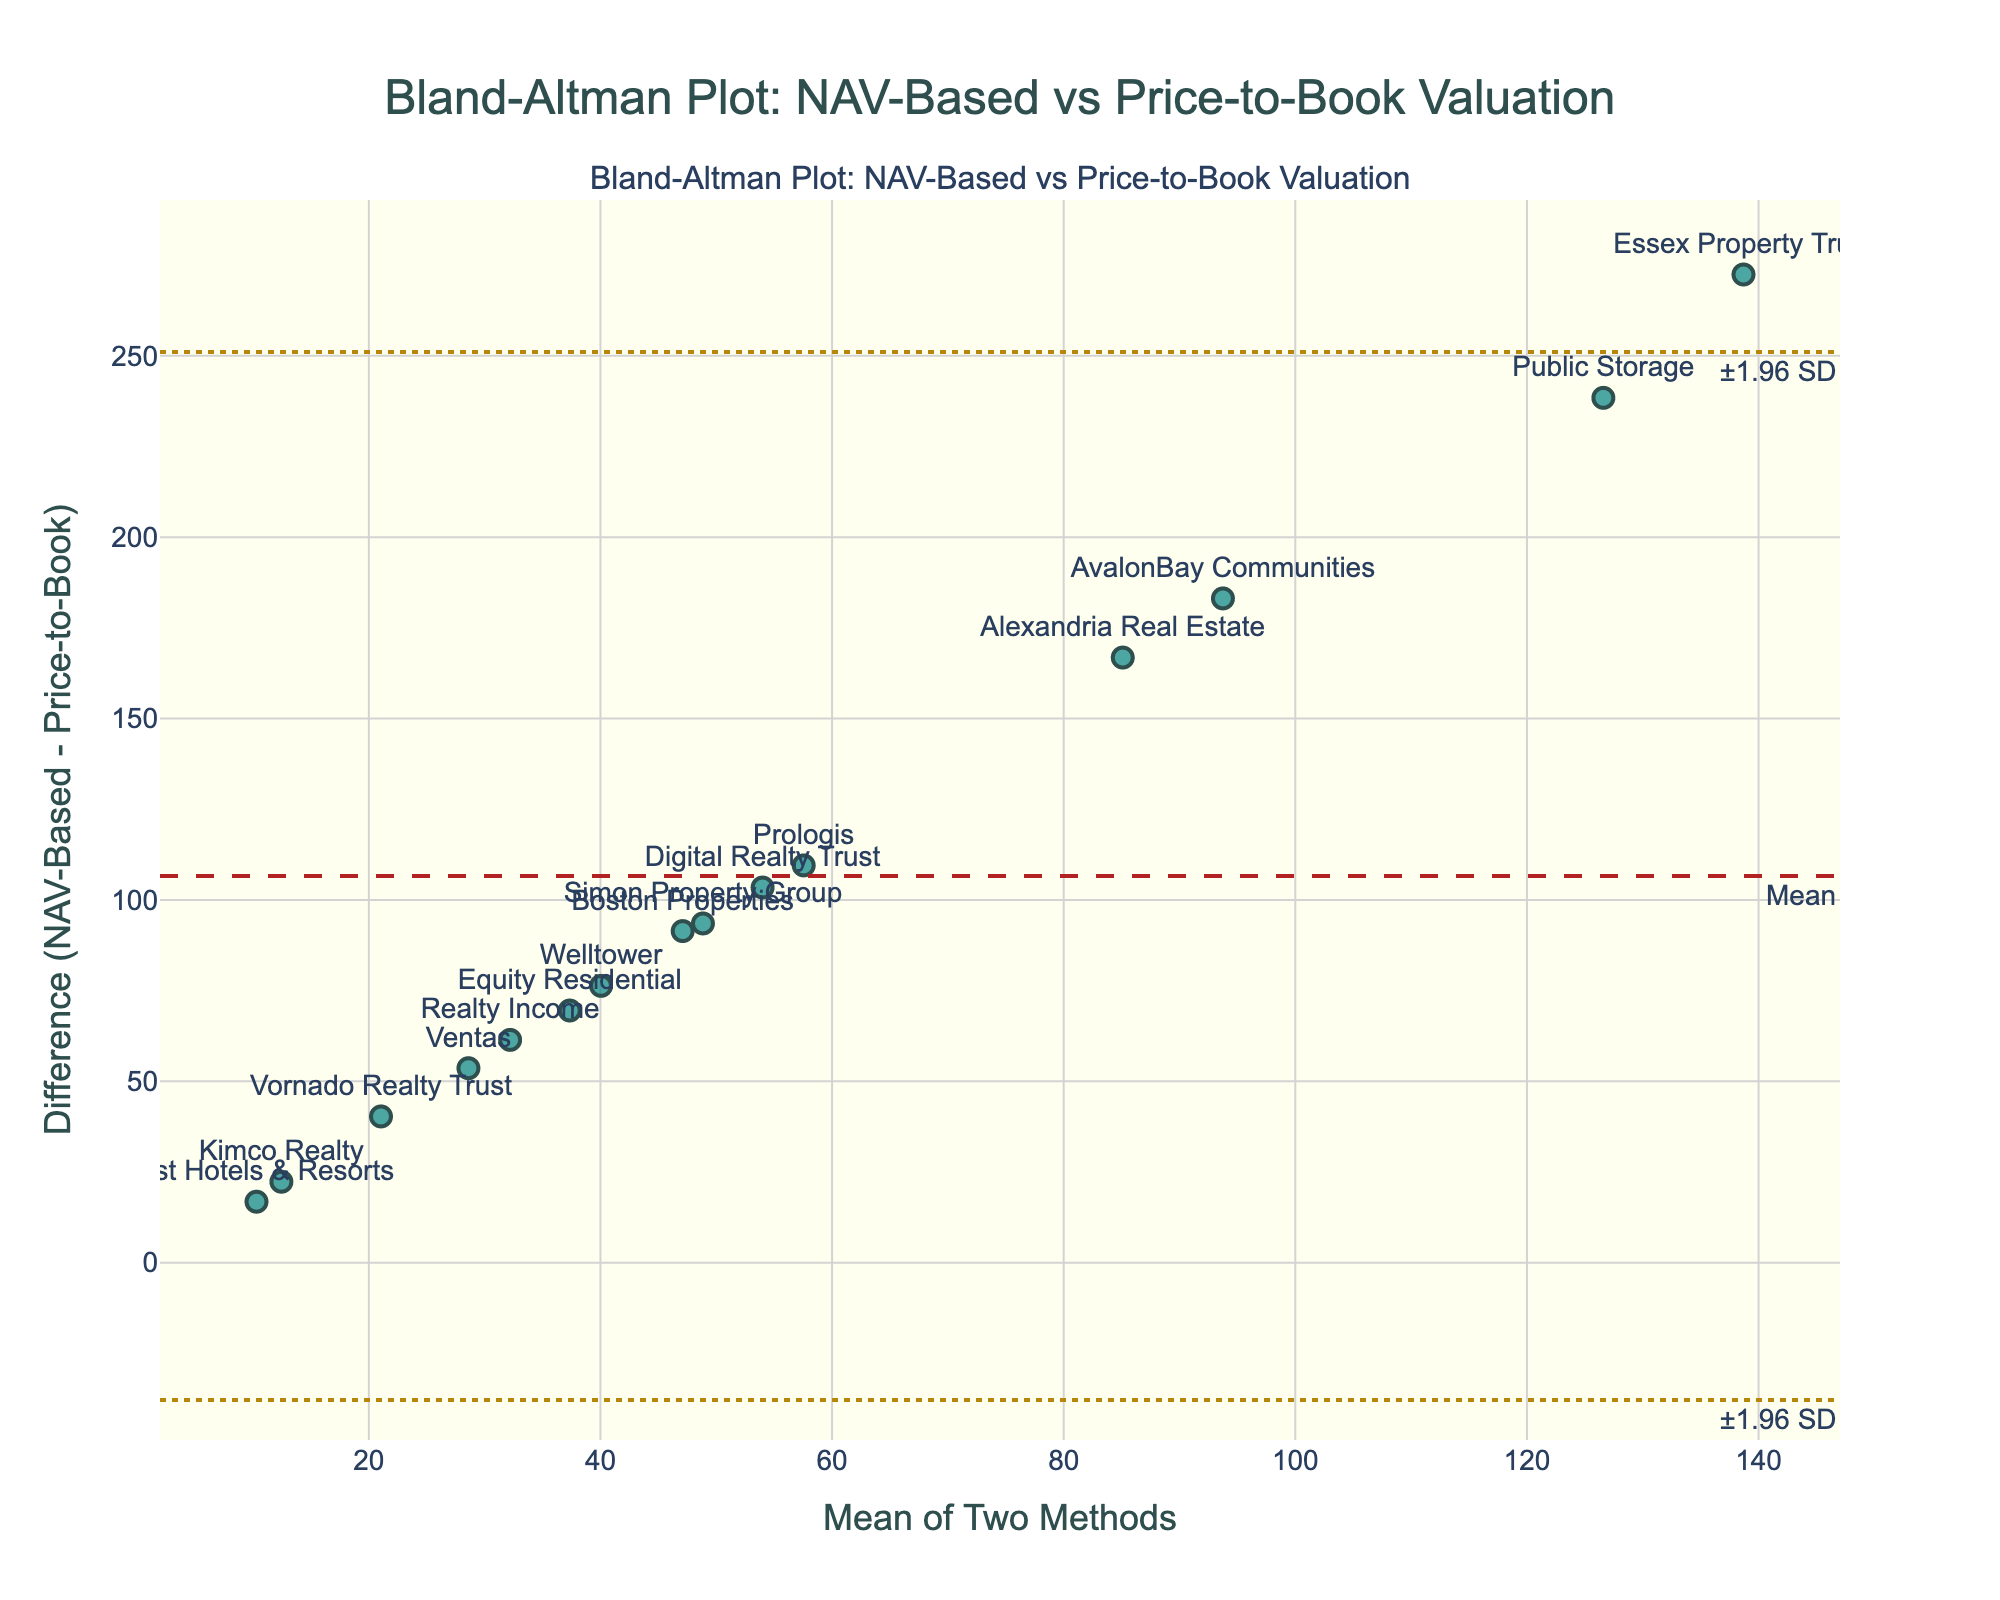What is the title of the plot? The title of the figure is prominently displayed at the top of the plot, which summarizes what the plot is about.
Answer: Bland-Altman Plot: NAV-Based vs Price-to-Book Valuation How many data points are there in the plot? Count the number of markers representing the data points in the scatter plot.
Answer: 15 What does the x-axis represent in the plot? The x-axis title indicates that it represents the mean value of the two methods being compared.
Answer: Mean of Two Methods What is the y-axis title of the plot? Look at the y-axis label provided in the plot, which describes what is being measured on this axis.
Answer: Difference (NAV-Based - Price-to-Book) What is the mean difference in the plot? Identify the horizontal dashed line labeled 'Mean' that runs across the plot. This line represents the average difference between the two valuation methods.
Answer: around 126.7 How many data points fall outside the limits of agreement? Count the number of points that lie above or below the two dashed lines representing the limits of agreement.
Answer: 3 Which REIT has the largest difference between NAV-Based Valuation and Price-to-Book Ratio? Identify the data point that has the greatest vertical distance from the y=0 line. Check the label attached to that point.
Answer: Public Storage Which two REITs have the most similar differences in valuation? Look for the two data points that are closest to each other in terms of their vertical position on the plot.
Answer: Host Hotels & Resorts and Kimco Realty Are there more data points above or below the mean difference line? Compare the number of points above the horizontal line representing the mean difference to the number of points below it.
Answer: Above What can you infer if most data points lie within the limits of agreement? Interpret the implication of seeing most data points within the two dotted lines representing limits of agreement: it suggests good agreement between the two methods.
Answer: The two methods generally agree 